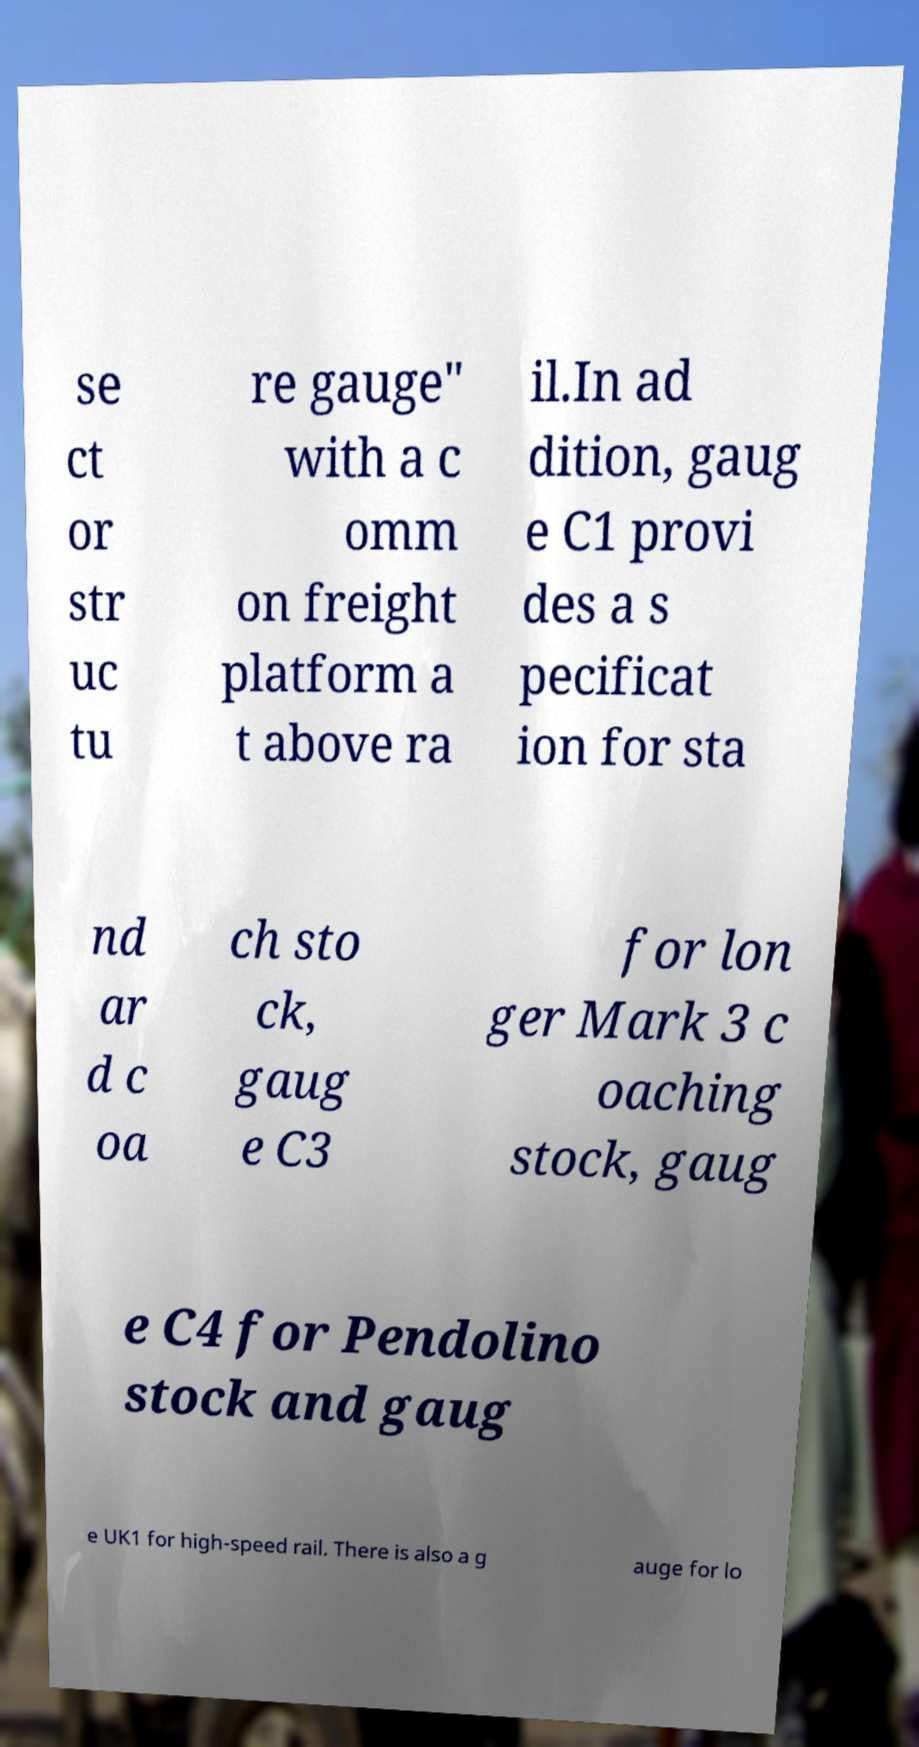What messages or text are displayed in this image? I need them in a readable, typed format. se ct or str uc tu re gauge" with a c omm on freight platform a t above ra il.In ad dition, gaug e C1 provi des a s pecificat ion for sta nd ar d c oa ch sto ck, gaug e C3 for lon ger Mark 3 c oaching stock, gaug e C4 for Pendolino stock and gaug e UK1 for high-speed rail. There is also a g auge for lo 